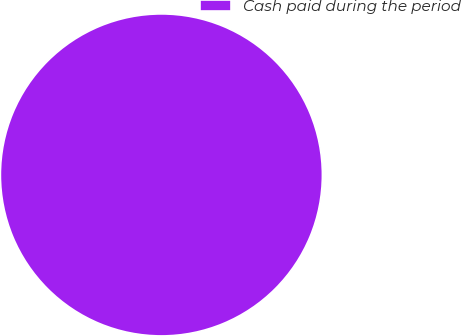<chart> <loc_0><loc_0><loc_500><loc_500><pie_chart><fcel>Cash paid during the period<nl><fcel>100.0%<nl></chart> 